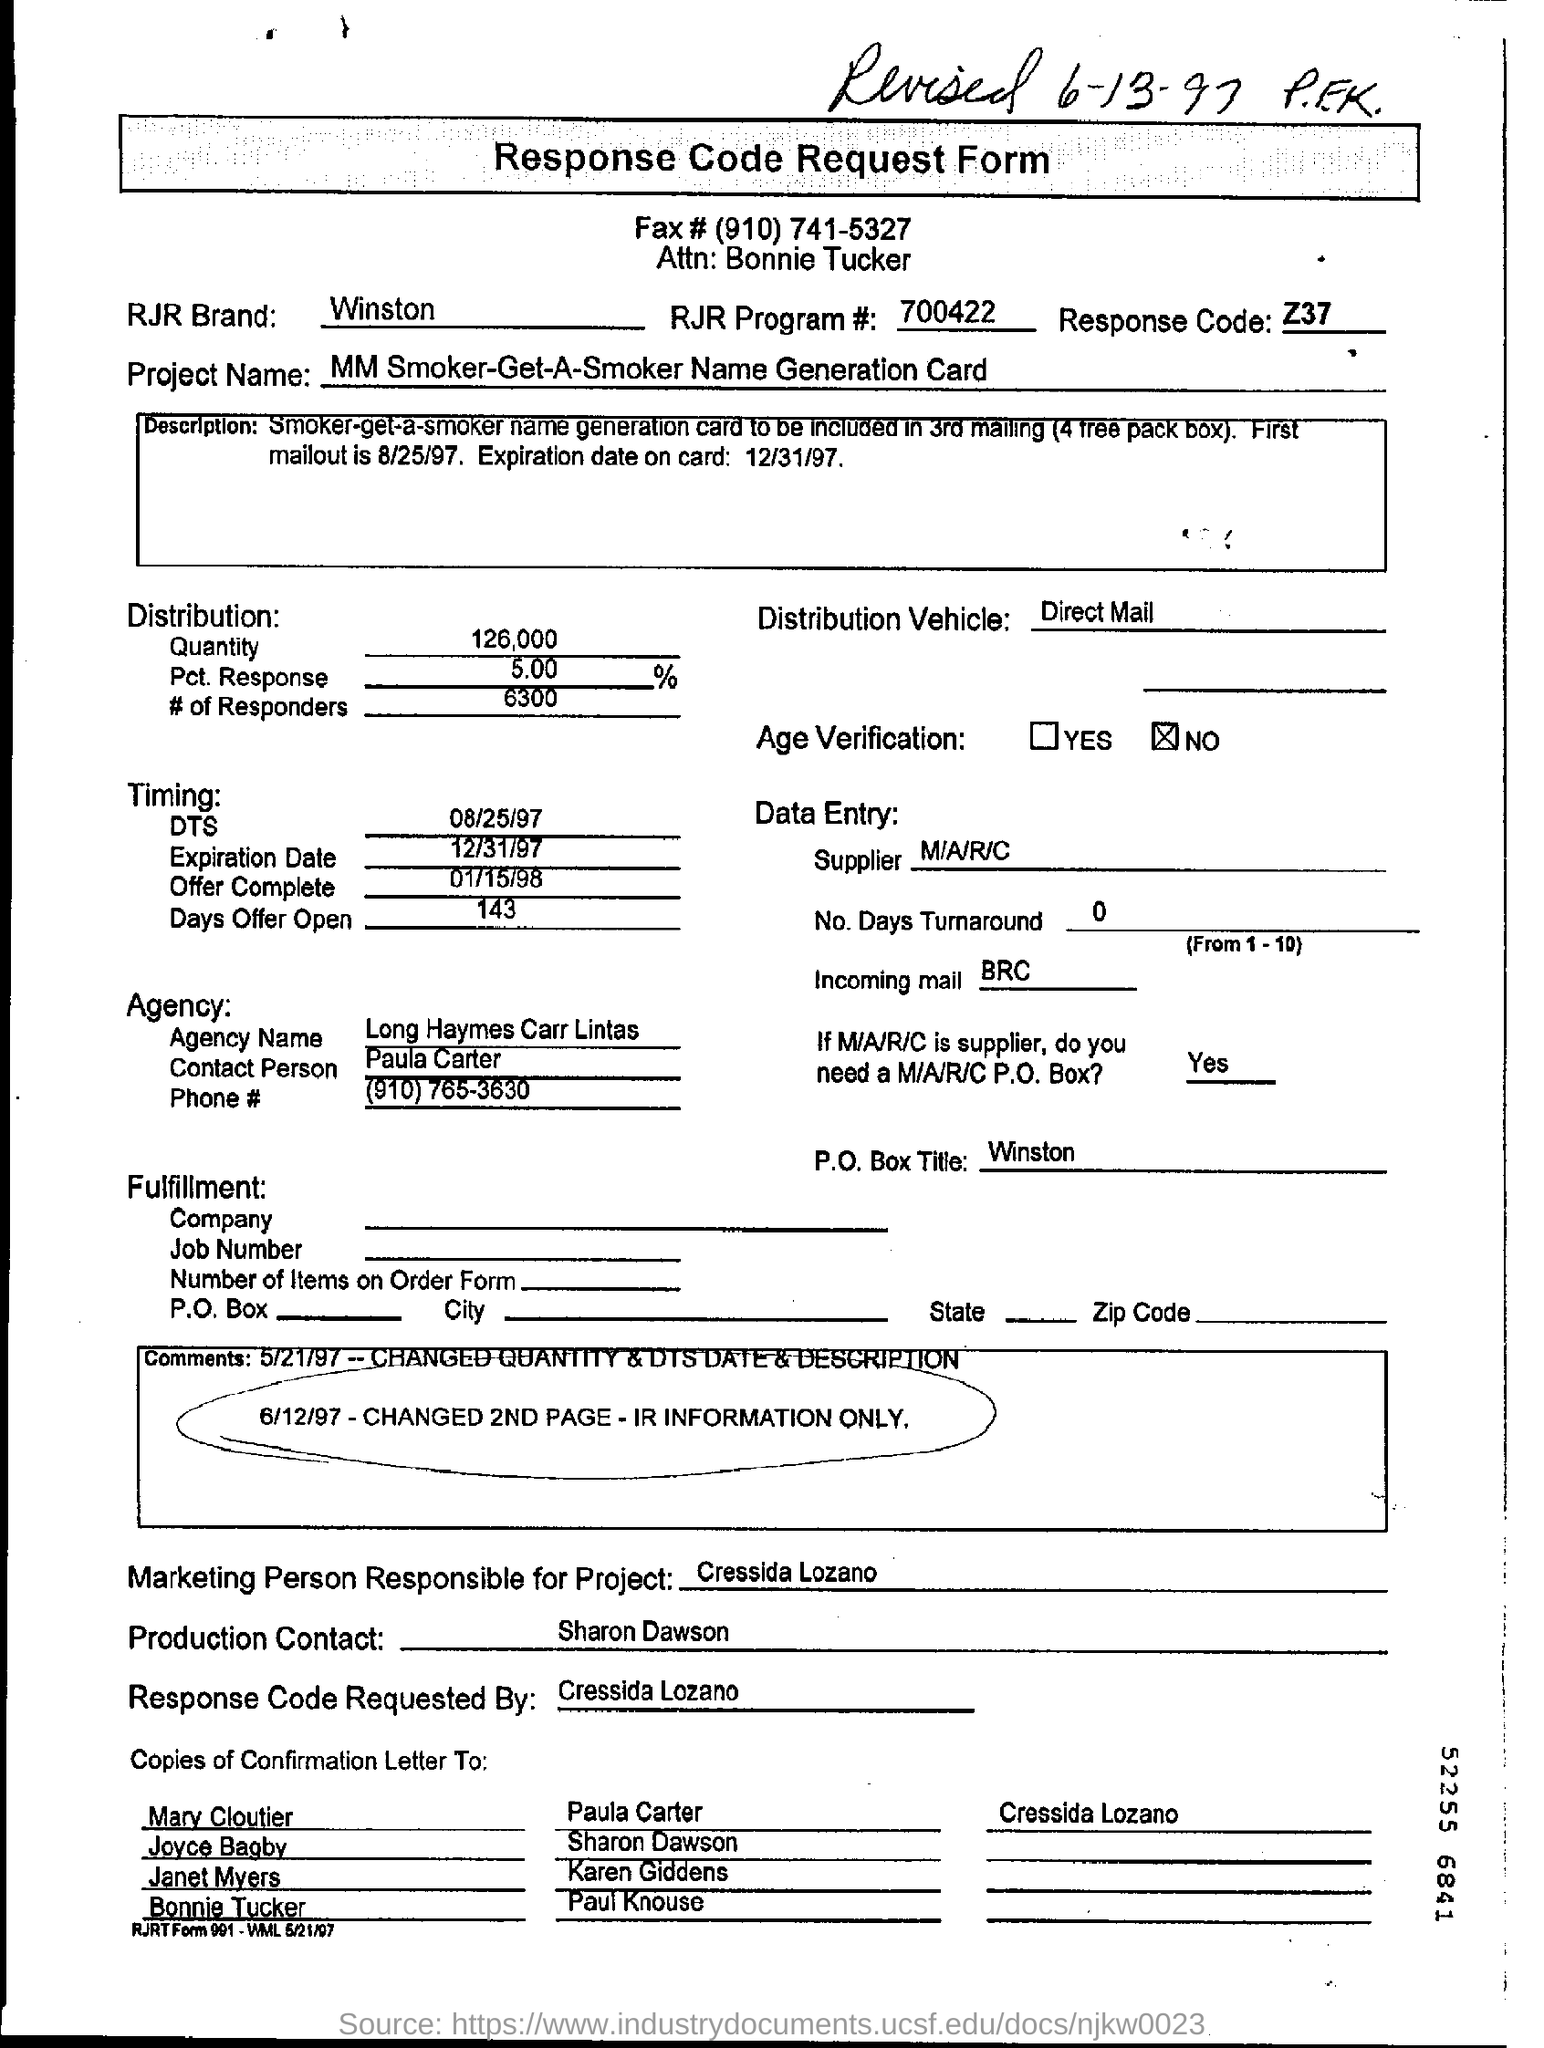What is the heading of the document?
Your response must be concise. Response Code Request Form. What is the Handwritten sentence on the top?
Keep it short and to the point. REvised 6-13-97 PEK. What is the RJR Brand?
Give a very brief answer. Winston. What is the Response Code?
Keep it short and to the point. Z37. 